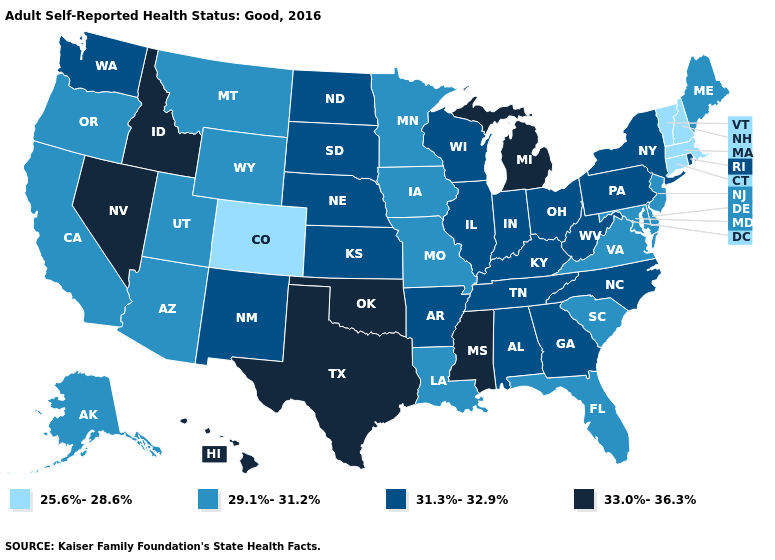What is the value of Mississippi?
Write a very short answer. 33.0%-36.3%. What is the value of Texas?
Quick response, please. 33.0%-36.3%. What is the value of Idaho?
Be succinct. 33.0%-36.3%. Name the states that have a value in the range 25.6%-28.6%?
Give a very brief answer. Colorado, Connecticut, Massachusetts, New Hampshire, Vermont. Does the map have missing data?
Concise answer only. No. Name the states that have a value in the range 33.0%-36.3%?
Short answer required. Hawaii, Idaho, Michigan, Mississippi, Nevada, Oklahoma, Texas. Does North Dakota have a higher value than Massachusetts?
Concise answer only. Yes. Which states hav the highest value in the South?
Answer briefly. Mississippi, Oklahoma, Texas. What is the value of West Virginia?
Answer briefly. 31.3%-32.9%. Which states hav the highest value in the MidWest?
Write a very short answer. Michigan. Name the states that have a value in the range 31.3%-32.9%?
Be succinct. Alabama, Arkansas, Georgia, Illinois, Indiana, Kansas, Kentucky, Nebraska, New Mexico, New York, North Carolina, North Dakota, Ohio, Pennsylvania, Rhode Island, South Dakota, Tennessee, Washington, West Virginia, Wisconsin. Name the states that have a value in the range 25.6%-28.6%?
Quick response, please. Colorado, Connecticut, Massachusetts, New Hampshire, Vermont. Name the states that have a value in the range 31.3%-32.9%?
Write a very short answer. Alabama, Arkansas, Georgia, Illinois, Indiana, Kansas, Kentucky, Nebraska, New Mexico, New York, North Carolina, North Dakota, Ohio, Pennsylvania, Rhode Island, South Dakota, Tennessee, Washington, West Virginia, Wisconsin. What is the highest value in the South ?
Short answer required. 33.0%-36.3%. 